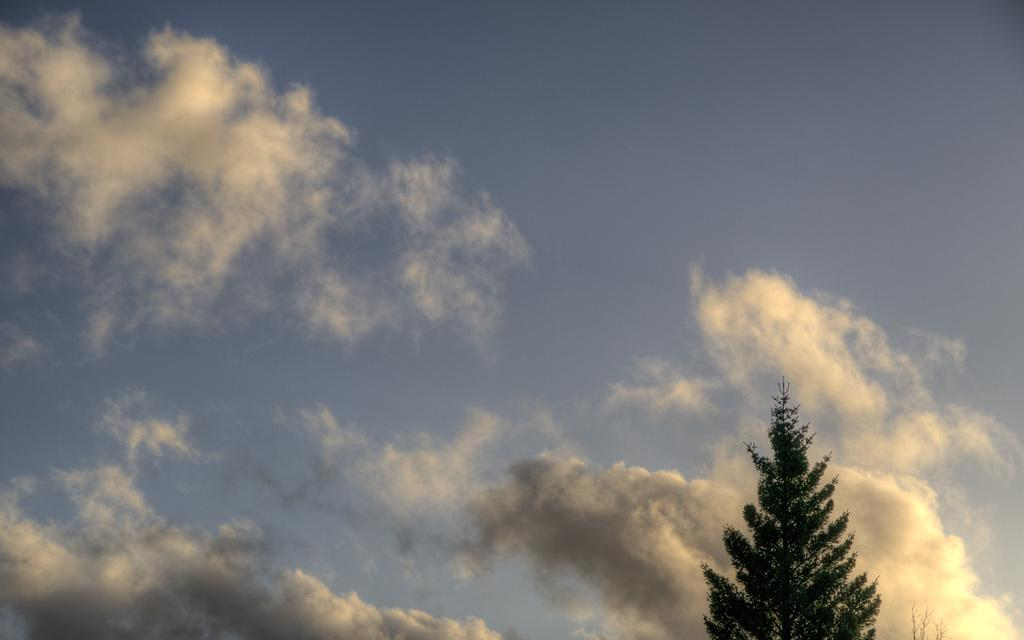What type of vegetation is present in the image? There is a tree in the image. How would you describe the sky in the image? The sky is cloudy in the image. What type of crack can be seen in the tree trunk in the image? There is no crack visible in the tree trunk in the image. What type of ship is sailing in the background of the image? There is no ship present in the image; it only features a tree and a cloudy sky. 